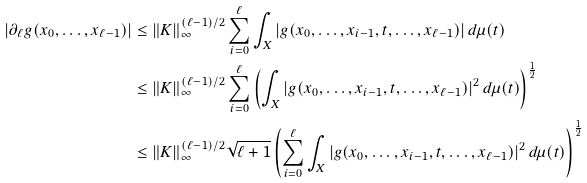<formula> <loc_0><loc_0><loc_500><loc_500>| \partial _ { \ell } g ( x _ { 0 } , \dots , x _ { \ell - 1 } ) | & \leq \| K \| _ { \infty } ^ { ( \ell - 1 ) / 2 } \sum _ { i = 0 } ^ { \ell } \int _ { X } | g ( x _ { 0 } , \dots , x _ { i - 1 } , t , \dots , x _ { \ell - 1 } ) | \, d \mu ( t ) \\ & \leq \| K \| _ { \infty } ^ { ( \ell - 1 ) / 2 } \sum _ { i = 0 } ^ { \ell } \left ( \int _ { X } | g ( x _ { 0 } , \dots , x _ { i - 1 } , t , \dots , x _ { \ell - 1 } ) | ^ { 2 } \, d \mu ( t ) \right ) ^ { \frac { 1 } { 2 } } \\ & \leq \| K \| _ { \infty } ^ { ( \ell - 1 ) / 2 } \sqrt { \ell + 1 } \left ( \sum _ { i = 0 } ^ { \ell } \int _ { X } | g ( x _ { 0 } , \dots , x _ { i - 1 } , t , \dots , x _ { \ell - 1 } ) | ^ { 2 } \, d \mu ( t ) \right ) ^ { \frac { 1 } { 2 } }</formula> 